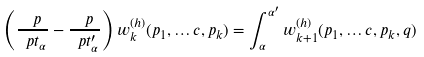Convert formula to latex. <formula><loc_0><loc_0><loc_500><loc_500>\left ( \frac { \ p } { \ p t _ { \alpha } } - \frac { \ p } { \ p t _ { \alpha } ^ { \prime } } \right ) w _ { k } ^ { ( h ) } ( p _ { 1 } , \dots c , p _ { k } ) = \int _ { \alpha } ^ { \alpha ^ { \prime } } w _ { k + 1 } ^ { ( h ) } ( p _ { 1 } , \dots c , p _ { k } , q )</formula> 